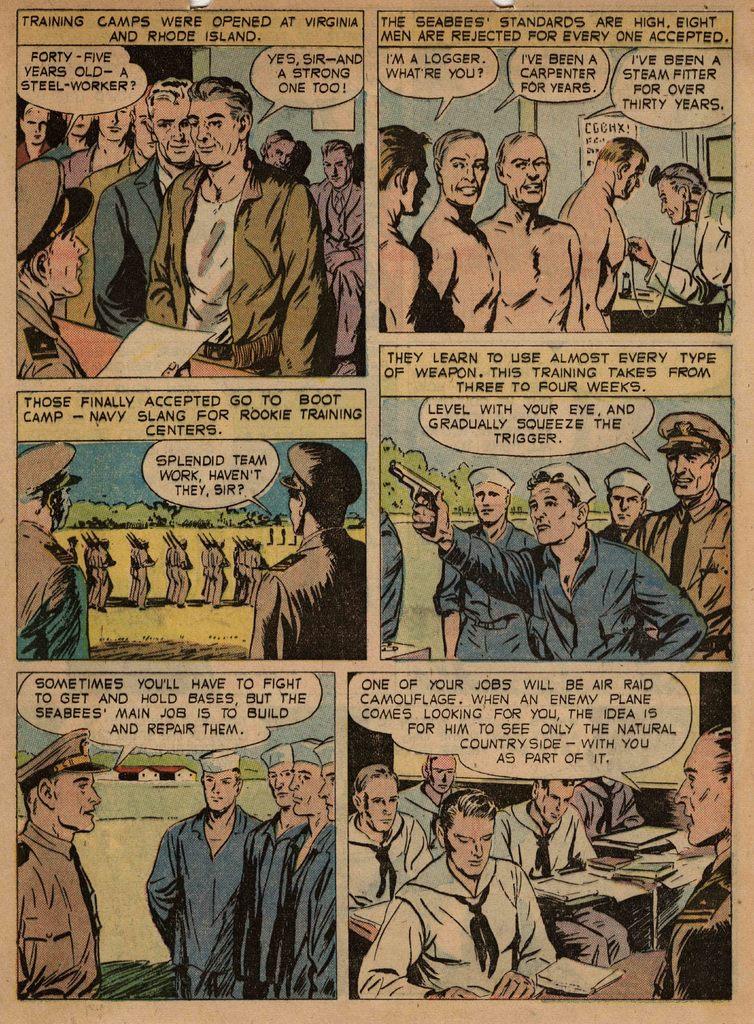What does it say on the yellow box in the first panel?
Offer a terse response. Training camps were opened at virginia and rhode island. What kind of camp?
Your answer should be compact. Training. 